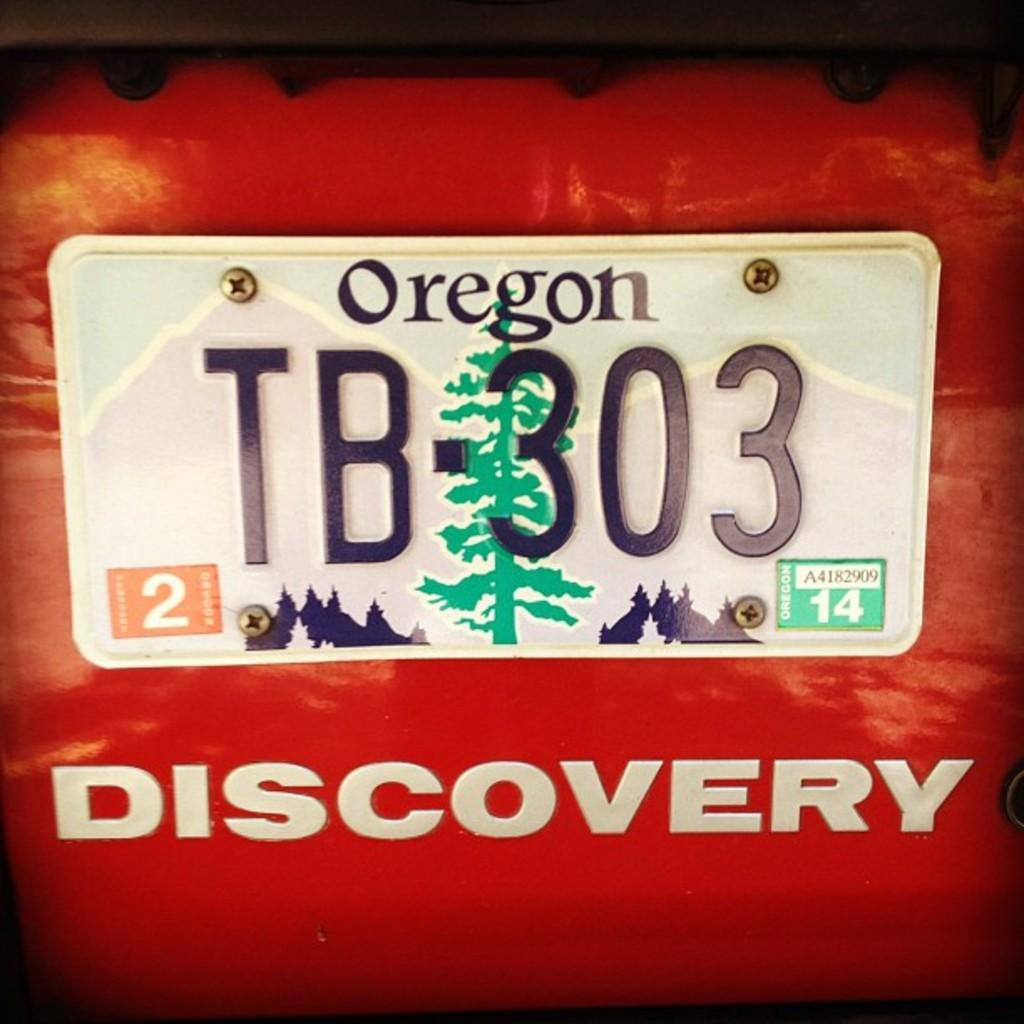<image>
Present a compact description of the photo's key features. A white car license plate from the state of Oregon 